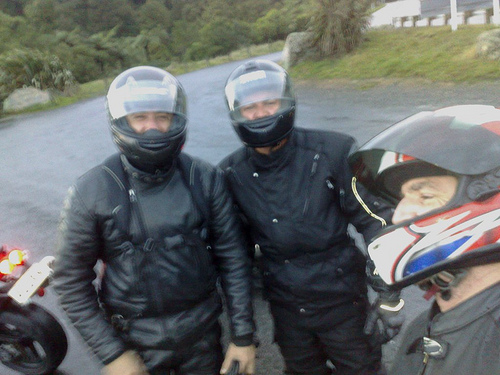<image>
Is there a man on the man? No. The man is not positioned on the man. They may be near each other, but the man is not supported by or resting on top of the man. Is the one man behind the another man? Yes. From this viewpoint, the one man is positioned behind the another man, with the another man partially or fully occluding the one man. Is there a plate in front of the forest? Yes. The plate is positioned in front of the forest, appearing closer to the camera viewpoint. 